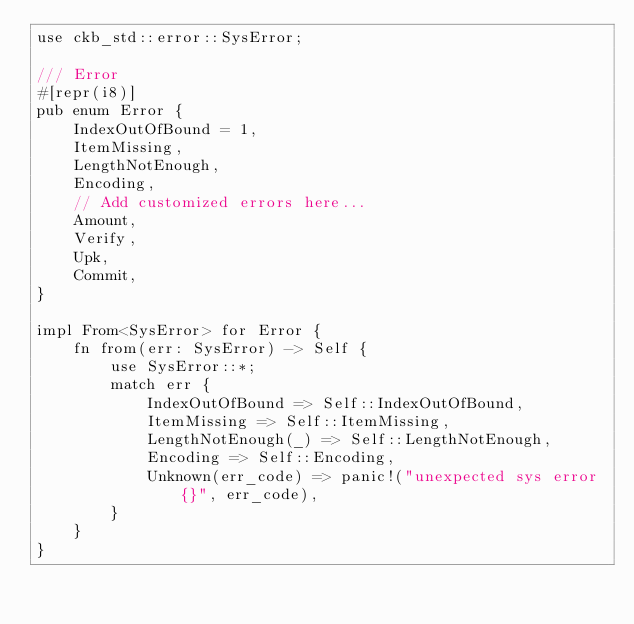<code> <loc_0><loc_0><loc_500><loc_500><_Rust_>use ckb_std::error::SysError;

/// Error
#[repr(i8)]
pub enum Error {
    IndexOutOfBound = 1,
    ItemMissing,
    LengthNotEnough,
    Encoding,
    // Add customized errors here...
    Amount,
    Verify,
    Upk,
    Commit,
}

impl From<SysError> for Error {
    fn from(err: SysError) -> Self {
        use SysError::*;
        match err {
            IndexOutOfBound => Self::IndexOutOfBound,
            ItemMissing => Self::ItemMissing,
            LengthNotEnough(_) => Self::LengthNotEnough,
            Encoding => Self::Encoding,
            Unknown(err_code) => panic!("unexpected sys error {}", err_code),
        }
    }
}
</code> 